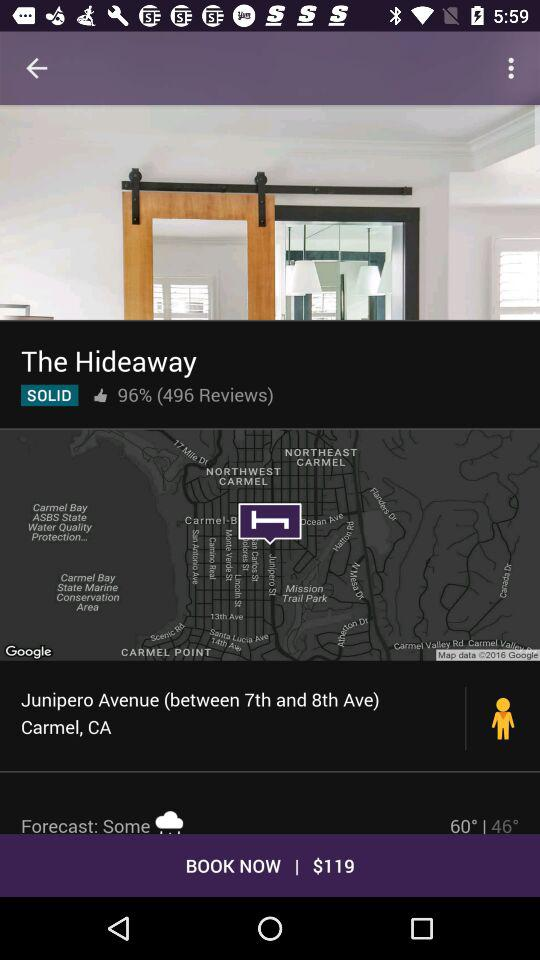How much is the booking amount? The booking amount is $119. 